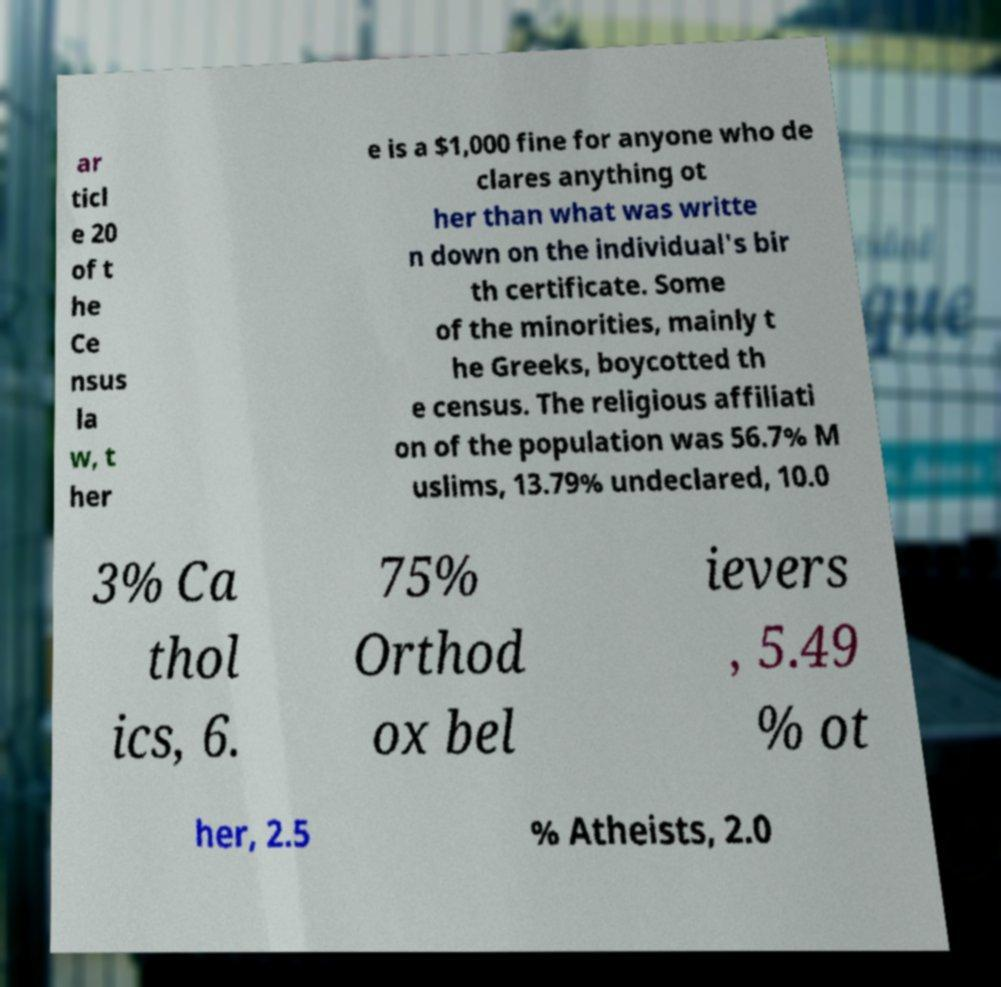For documentation purposes, I need the text within this image transcribed. Could you provide that? ar ticl e 20 of t he Ce nsus la w, t her e is a $1,000 fine for anyone who de clares anything ot her than what was writte n down on the individual's bir th certificate. Some of the minorities, mainly t he Greeks, boycotted th e census. The religious affiliati on of the population was 56.7% M uslims, 13.79% undeclared, 10.0 3% Ca thol ics, 6. 75% Orthod ox bel ievers , 5.49 % ot her, 2.5 % Atheists, 2.0 